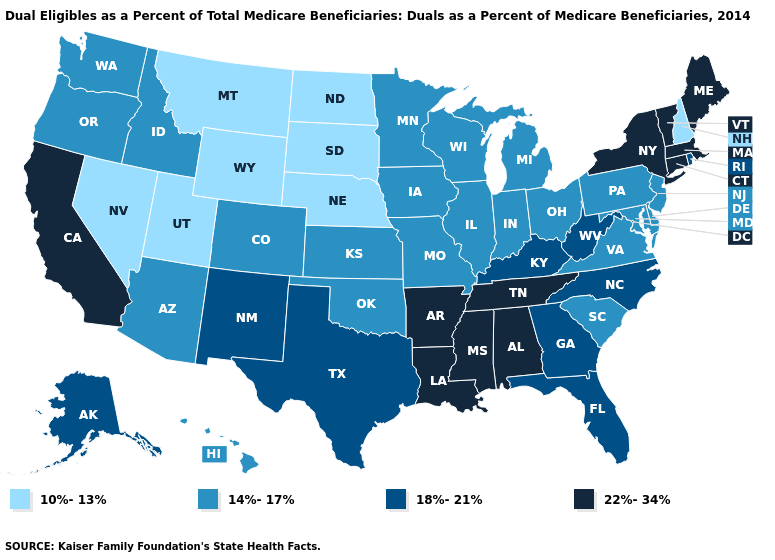How many symbols are there in the legend?
Write a very short answer. 4. Does New Hampshire have the lowest value in the Northeast?
Answer briefly. Yes. Does Connecticut have the same value as Massachusetts?
Write a very short answer. Yes. Name the states that have a value in the range 10%-13%?
Give a very brief answer. Montana, Nebraska, Nevada, New Hampshire, North Dakota, South Dakota, Utah, Wyoming. What is the value of Washington?
Give a very brief answer. 14%-17%. Among the states that border Montana , which have the highest value?
Concise answer only. Idaho. Among the states that border Minnesota , which have the highest value?
Concise answer only. Iowa, Wisconsin. Among the states that border Montana , does North Dakota have the highest value?
Quick response, please. No. Among the states that border Oregon , does Washington have the lowest value?
Answer briefly. No. What is the highest value in the USA?
Quick response, please. 22%-34%. Is the legend a continuous bar?
Be succinct. No. Does Kentucky have the same value as Oklahoma?
Write a very short answer. No. What is the lowest value in the MidWest?
Be succinct. 10%-13%. What is the value of New Hampshire?
Give a very brief answer. 10%-13%. 